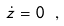<formula> <loc_0><loc_0><loc_500><loc_500>\dot { z } = 0 \ ,</formula> 